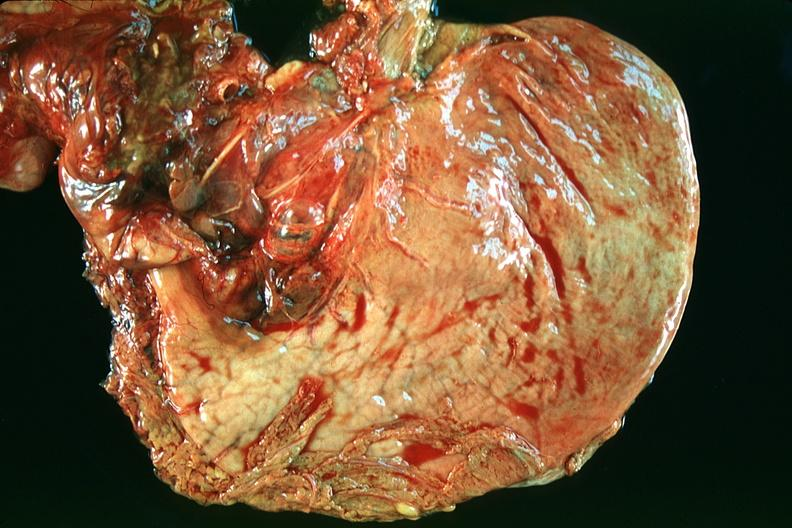where does this belong to?
Answer the question using a single word or phrase. Gastrointestinal system 